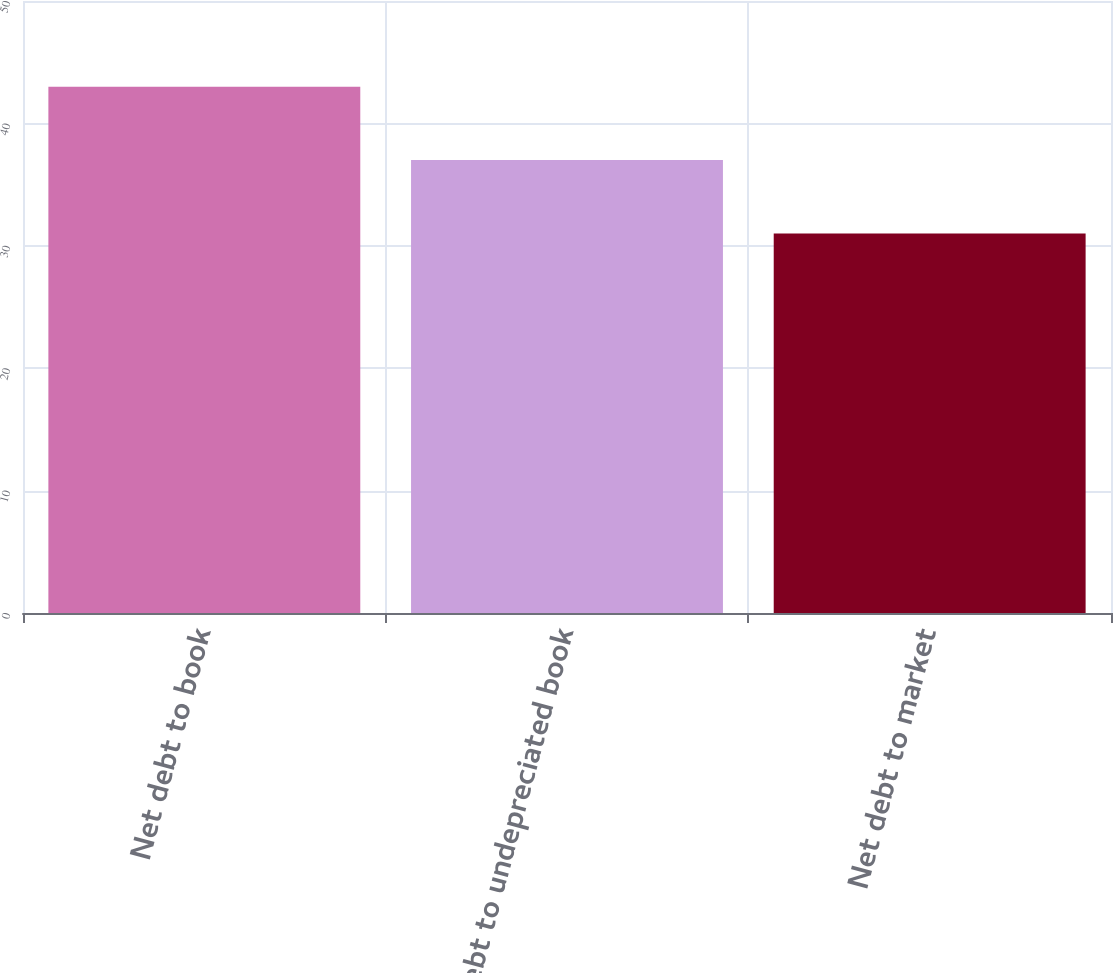Convert chart to OTSL. <chart><loc_0><loc_0><loc_500><loc_500><bar_chart><fcel>Net debt to book<fcel>Net debt to undepreciated book<fcel>Net debt to market<nl><fcel>43<fcel>37<fcel>31<nl></chart> 